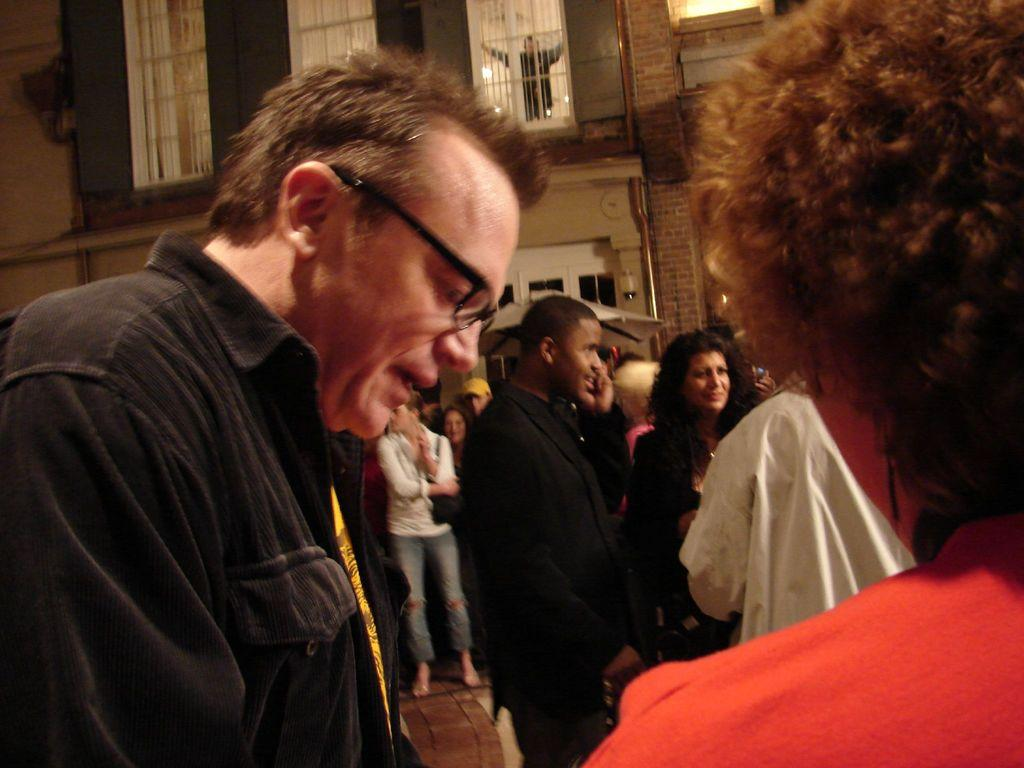What can be seen in the image? There are people standing in the image. What is visible in the background of the image? There is a building in the background of the image. How many women and girls are present in the image? The provided facts do not mention the gender or age of the people in the image, so it cannot be determined from the image. 